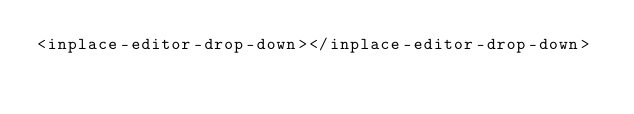Convert code to text. <code><loc_0><loc_0><loc_500><loc_500><_HTML_><inplace-editor-drop-down></inplace-editor-drop-down>
</code> 